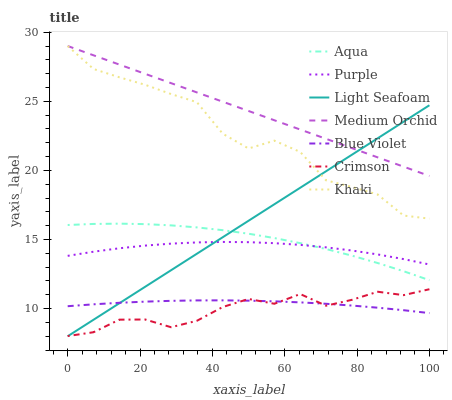Does Purple have the minimum area under the curve?
Answer yes or no. No. Does Purple have the maximum area under the curve?
Answer yes or no. No. Is Purple the smoothest?
Answer yes or no. No. Is Purple the roughest?
Answer yes or no. No. Does Purple have the lowest value?
Answer yes or no. No. Does Purple have the highest value?
Answer yes or no. No. Is Purple less than Medium Orchid?
Answer yes or no. Yes. Is Khaki greater than Aqua?
Answer yes or no. Yes. Does Purple intersect Medium Orchid?
Answer yes or no. No. 